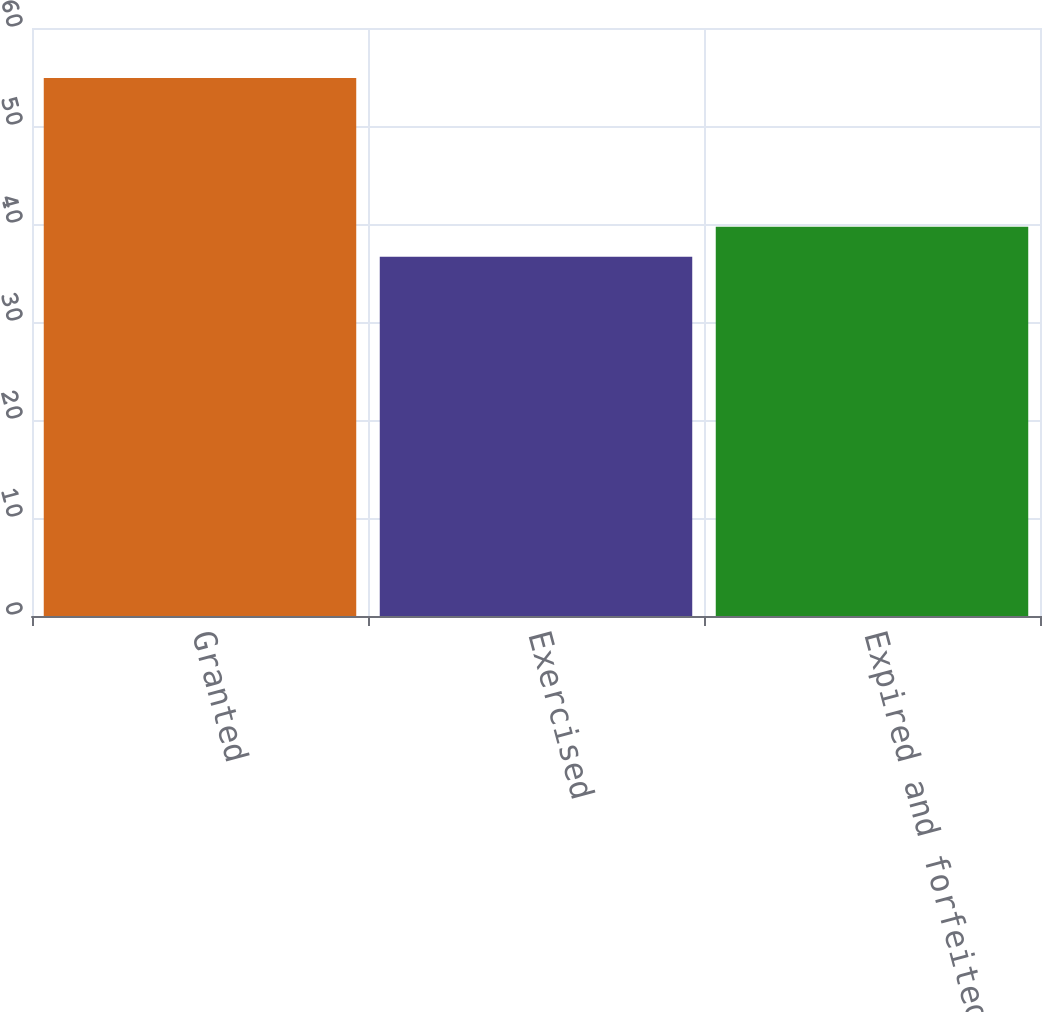Convert chart to OTSL. <chart><loc_0><loc_0><loc_500><loc_500><bar_chart><fcel>Granted<fcel>Exercised<fcel>Expired and forfeited<nl><fcel>54.91<fcel>36.66<fcel>39.73<nl></chart> 